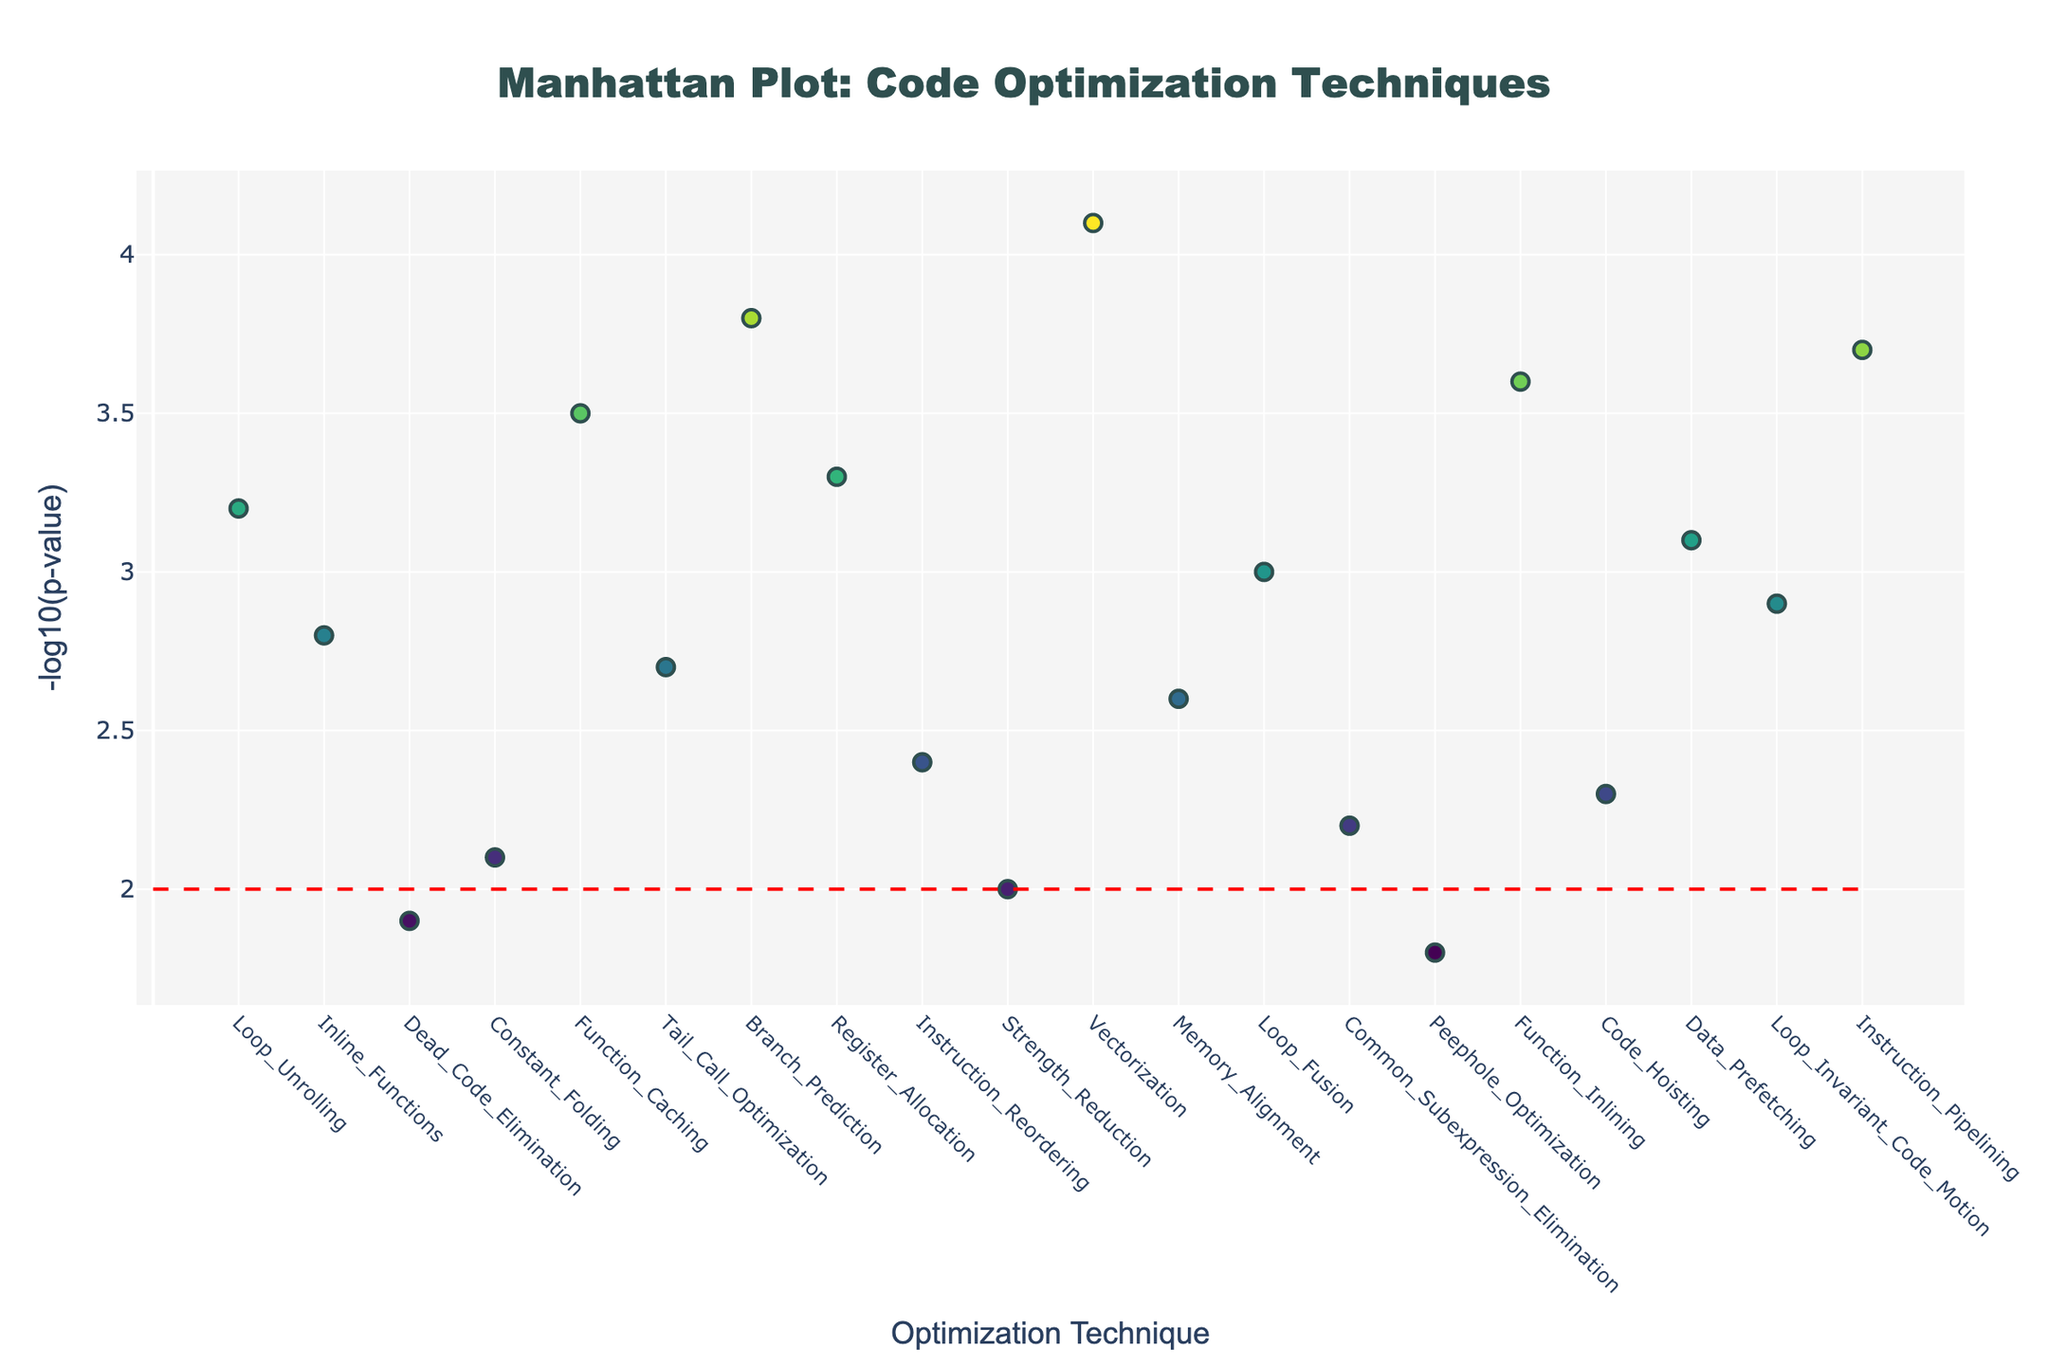What is the title of the plot? The title is usually placed at the top of the plot. It states the main topic or focus of the visual representation. The title here is "Manhattan Plot: Code Optimization Techniques"
Answer: Manhattan Plot: Code Optimization Techniques How many optimization techniques are represented in the plot? To find the number of optimization techniques, count the number of points or unique positions along the x-axis. Each point corresponds to a different technique.
Answer: 20 Which optimization technique has the highest -log10(p-value)? Look for the point with the highest y-axis value and note its corresponding x-axis label for the technique name. The highest -log10(p-value) is 4.1. The technique is 'Vectorization'.
Answer: Vectorization How many techniques have a -log10(p-value) greater than 3.0? Count the number of points above the horizontal threshold line at y=2 and specifically check which are above y=3.
Answer: 8 Which technique is positioned at the 10th position in the plot? Check the x-axis label for position 10 to find the technique. The label at position 10 corresponds to 'Strength Reduction'.
Answer: Strength Reduction What is the difference in -log10(p-value) between 'Function Inlining' and 'Dead Code Elimination'? Find the y-values of 'Function Inlining' and 'Dead Code Elimination', then subtract the lower value from the higher value. Function Inlining's y-value is 3.6 and Dead Code Elimination's y-value is 1.9. Their difference is 3.6-1.9 = 1.7.
Answer: 1.7 How does 'Branch Prediction' compare in -log10(p-value) to 'Instruction Pipelining'? Check the y-values for both techniques and compare them. Branch Prediction's y-value is 3.8 and Instruction Pipelining's is 3.7. Branch Prediction has a slightly higher -log10(p-value).
Answer: Branch Prediction is slightly higher Which optimization technique stands just below the significance threshold of -log10(p-value)=2? Find the technique point nearest and just below the horizontal line at y=2. 'Peephole Optimization' with a y-value of 1.8 fits this description.
Answer: Peephole Optimization What are the optimization techniques yielding the top three -log10(p-values)? Identify the three highest points on the plot and note their corresponding technique names. The highest values are Vectorization (4.1), Function Inlining (3.6), and Branch Prediction (3.8).
Answer: Vectorization, Branch Prediction, Function Inlining Which technique at position 18 has a significant impact on execution speed? Check the y-value of the technique at position 18 and see if it exceeds the threshold of 2. The technique is 'Data Prefetching' with a y-value of 3.1, which is significant.
Answer: Data Prefetching 